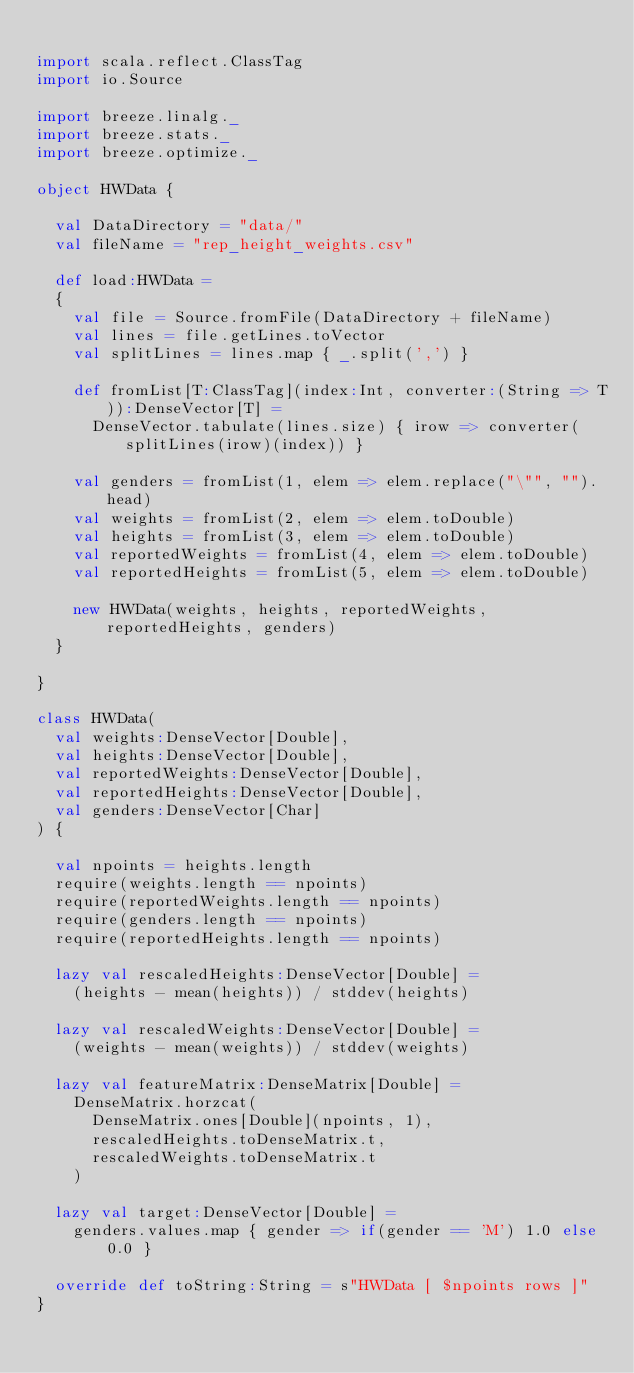<code> <loc_0><loc_0><loc_500><loc_500><_Scala_>
import scala.reflect.ClassTag
import io.Source

import breeze.linalg._
import breeze.stats._
import breeze.optimize._

object HWData {
  
  val DataDirectory = "data/"
  val fileName = "rep_height_weights.csv"

  def load:HWData =
  {
    val file = Source.fromFile(DataDirectory + fileName)
    val lines = file.getLines.toVector
    val splitLines = lines.map { _.split(',') }

    def fromList[T:ClassTag](index:Int, converter:(String => T)):DenseVector[T] =
      DenseVector.tabulate(lines.size) { irow => converter(splitLines(irow)(index)) }

    val genders = fromList(1, elem => elem.replace("\"", "").head)
    val weights = fromList(2, elem => elem.toDouble)
    val heights = fromList(3, elem => elem.toDouble)
    val reportedWeights = fromList(4, elem => elem.toDouble)
    val reportedHeights = fromList(5, elem => elem.toDouble)

    new HWData(weights, heights, reportedWeights, reportedHeights, genders)
  }

}

class HWData(
  val weights:DenseVector[Double],
  val heights:DenseVector[Double],
  val reportedWeights:DenseVector[Double],
  val reportedHeights:DenseVector[Double],
  val genders:DenseVector[Char]
) {

  val npoints = heights.length
  require(weights.length == npoints)
  require(reportedWeights.length == npoints)
  require(genders.length == npoints)
  require(reportedHeights.length == npoints)

  lazy val rescaledHeights:DenseVector[Double] =
    (heights - mean(heights)) / stddev(heights)

  lazy val rescaledWeights:DenseVector[Double] =
    (weights - mean(weights)) / stddev(weights)

  lazy val featureMatrix:DenseMatrix[Double] =
    DenseMatrix.horzcat( 
      DenseMatrix.ones[Double](npoints, 1), 
      rescaledHeights.toDenseMatrix.t,
      rescaledWeights.toDenseMatrix.t
    )

  lazy val target:DenseVector[Double] =
    genders.values.map { gender => if(gender == 'M') 1.0 else 0.0 }

  override def toString:String = s"HWData [ $npoints rows ]"
}

</code> 